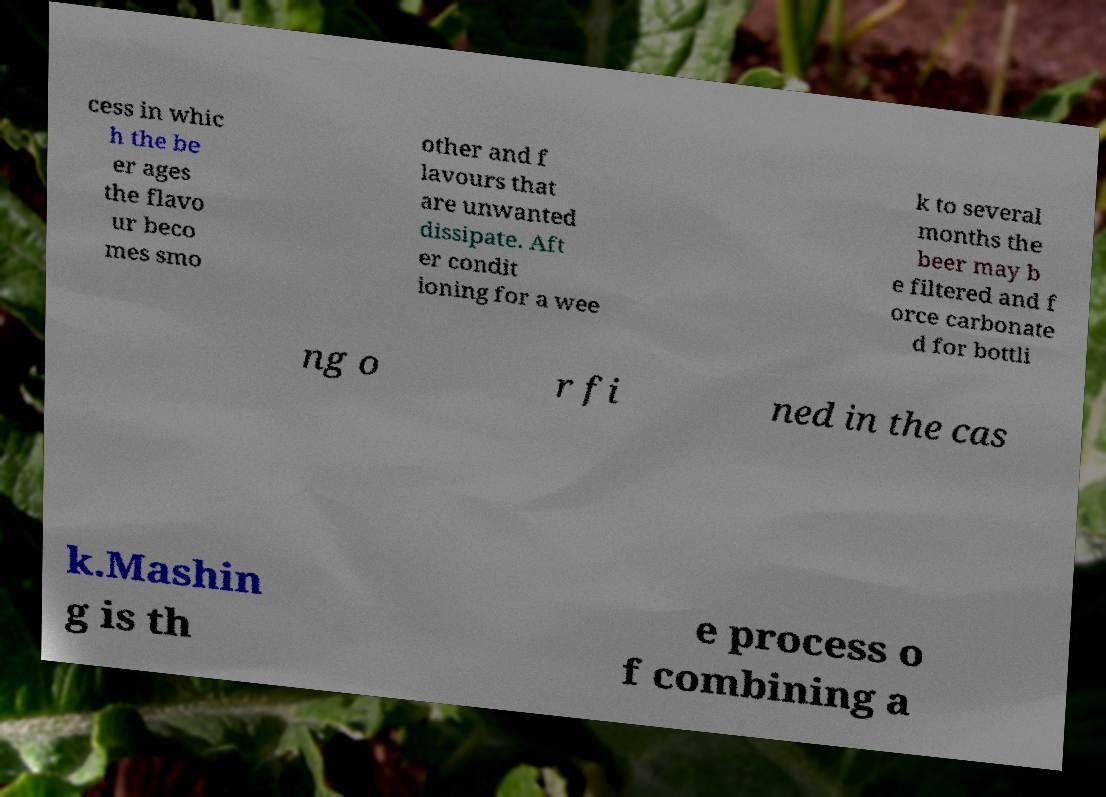For documentation purposes, I need the text within this image transcribed. Could you provide that? cess in whic h the be er ages the flavo ur beco mes smo other and f lavours that are unwanted dissipate. Aft er condit ioning for a wee k to several months the beer may b e filtered and f orce carbonate d for bottli ng o r fi ned in the cas k.Mashin g is th e process o f combining a 